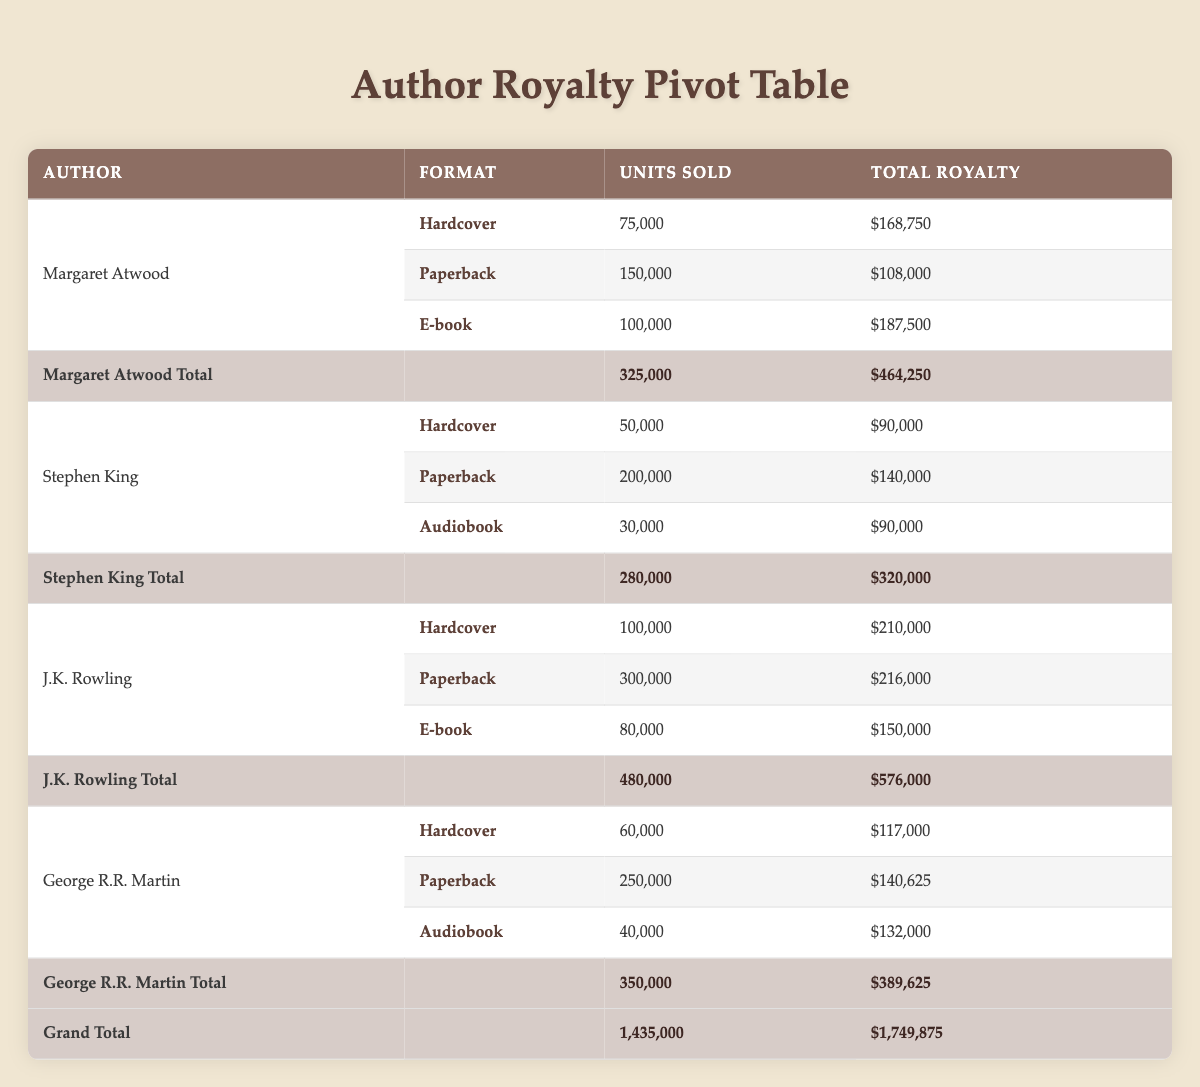What is the total royalty payment for J.K. Rowling's hardcover books? The table shows that J.K. Rowling received a total royalty of $210,000 for her hardcover book "Harry Potter and the Philosopher's Stone."
Answer: $210,000 How many units of George R.R. Martin's paperback book were sold? According to the table, George R.R. Martin's paperback book "A Game of Thrones" sold 250,000 units.
Answer: 250,000 Did Stephen King earn more from his paperback or audiobook format? The total royalty from the paperback format was $140,000, while from the audiobook, it was $90,000. Therefore, Stephen King earned more from the paperback.
Answer: Yes What is the average total royalty earned by each author listed in the table? The total royalties for each author are as follows: Margaret Atwood - $464,250, Stephen King - $320,000, J.K. Rowling - $576,000, and George R.R. Martin - $389,625. Adding these gives $1,749,875, divided by 4 gives an average of $437,468.75.
Answer: $437,468.75 What was the total number of units sold across all formats for Margaret Atwood? Margaret Atwood sold 75,000 hardcover, 150,000 paperback, and 100,000 e-book units. Summing these gives 325,000 units total.
Answer: 325,000 Which book format provided the highest royalty for George R.R. Martin? The formats show that he earned $132,000 from the audiobook, $140,625 from the paperback, and $117,000 from hardcover. Hence, the paperback format generated the highest royalty.
Answer: Paperback How much total royalty did all authors combined earn from audiobook formats? The table states that Stephen King earned $90,000, and George R.R. Martin earned $132,000 from audiobooks. Summing these amounts results in $222,000 total royalties from audiobook formats.
Answer: $222,000 Which author earned the least total royalty, and what was the amount? From the total royalties, Stephen King earned $320,000, which is less than Margaret Atwood's $464,250, J.K. Rowling's $576,000, and George R.R. Martin's $389,625. Hence, Stephen King earned the least.
Answer: Stephen King; $320,000 What percentage of J.K. Rowling's total royalties came from the paperback format? J.K. Rowling earned $216,000 from the paperback format and $576,000 overall. Calculating gives (216,000 / 576,000) * 100 = 37.5%.
Answer: 37.5% 